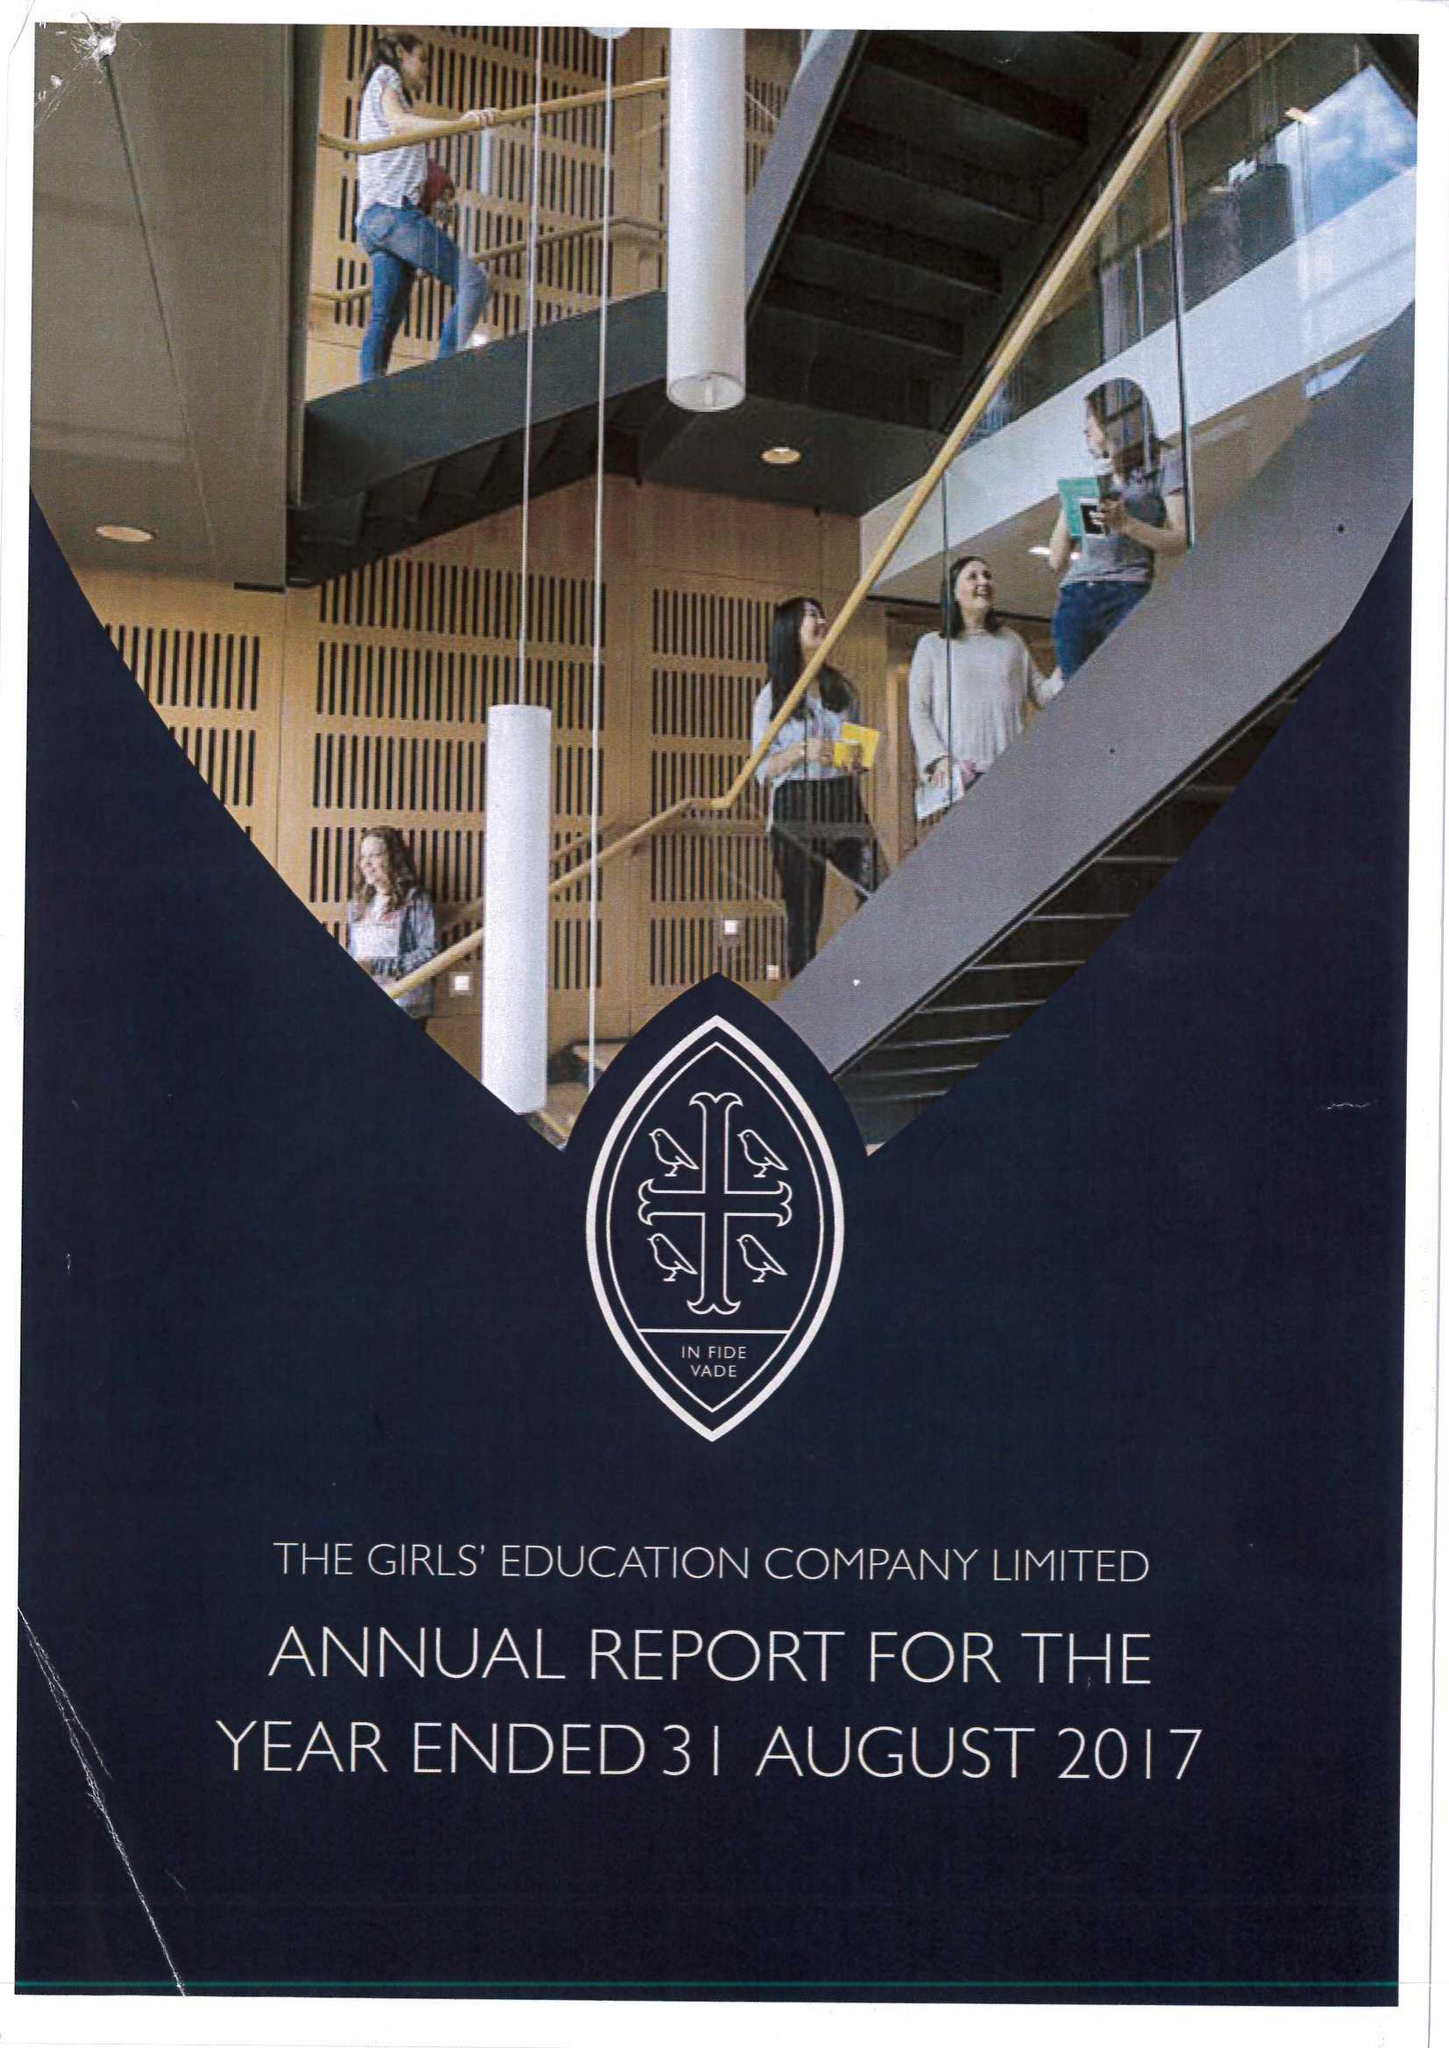What is the value for the address__street_line?
Answer the question using a single word or phrase. ABBEY WAY 